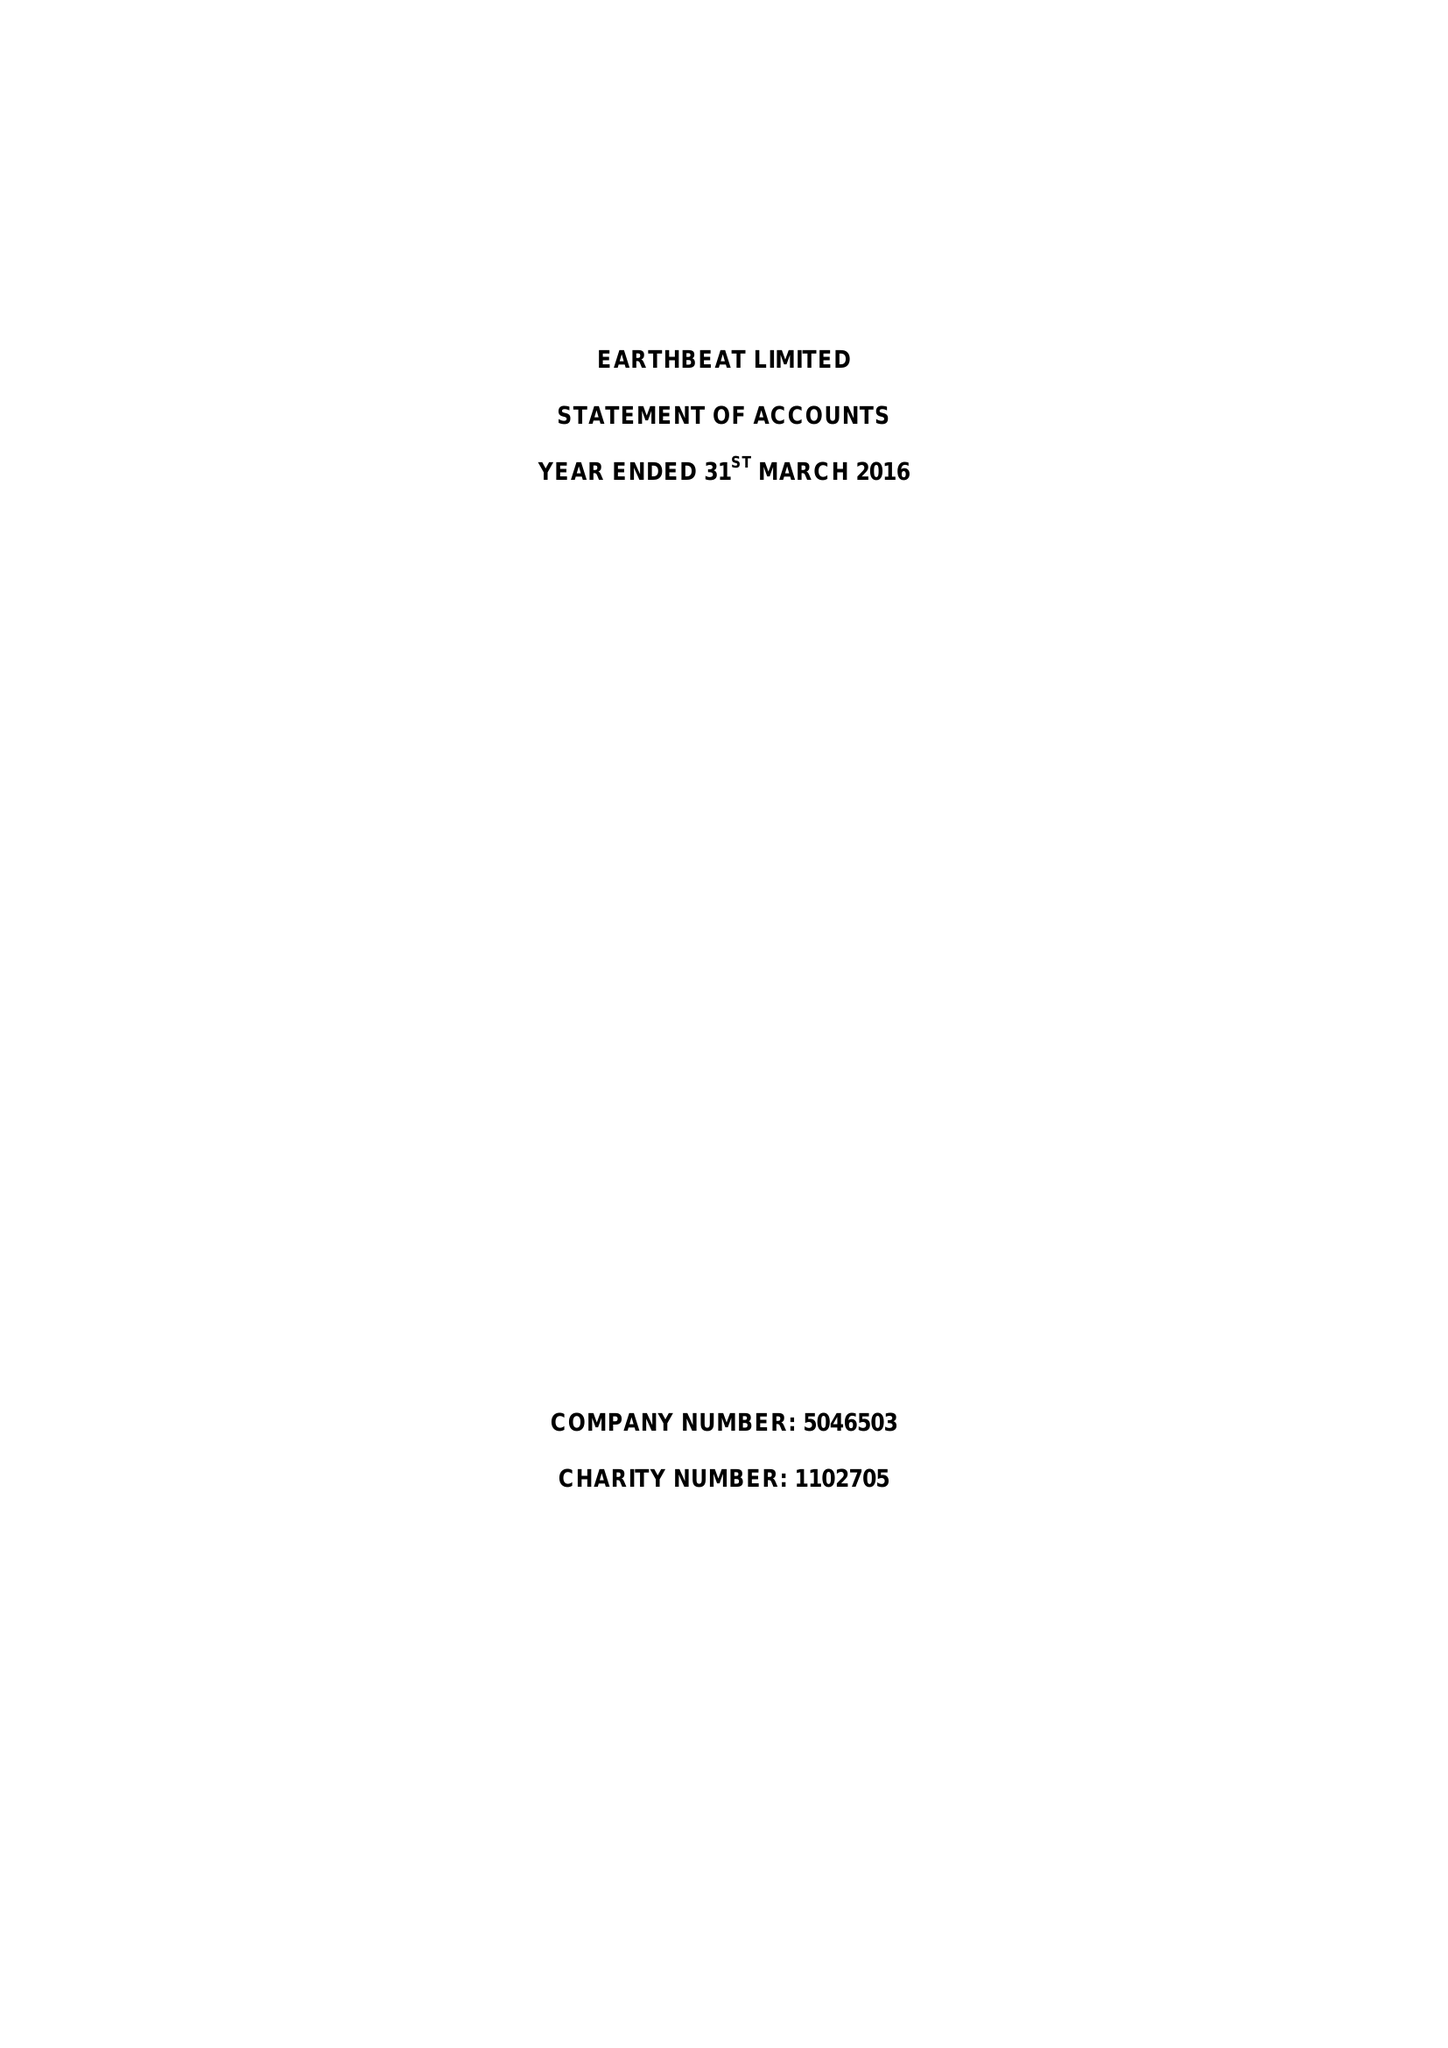What is the value for the charity_name?
Answer the question using a single word or phrase. Earthbeat Ltd. 